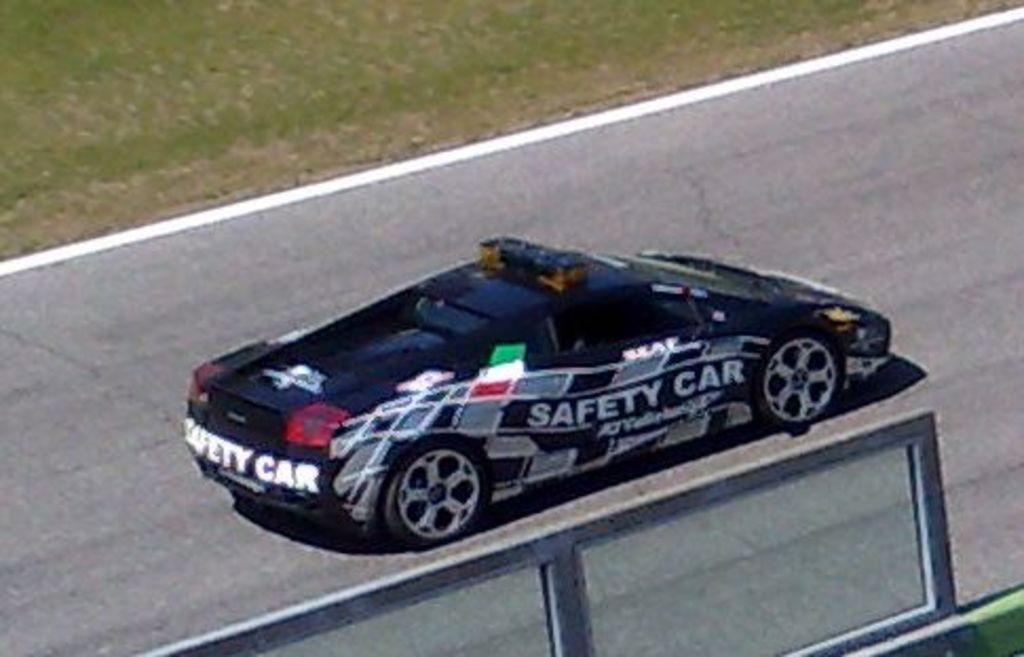How would you summarize this image in a sentence or two? In this image we can see car on the road. At the top there is a grass. 